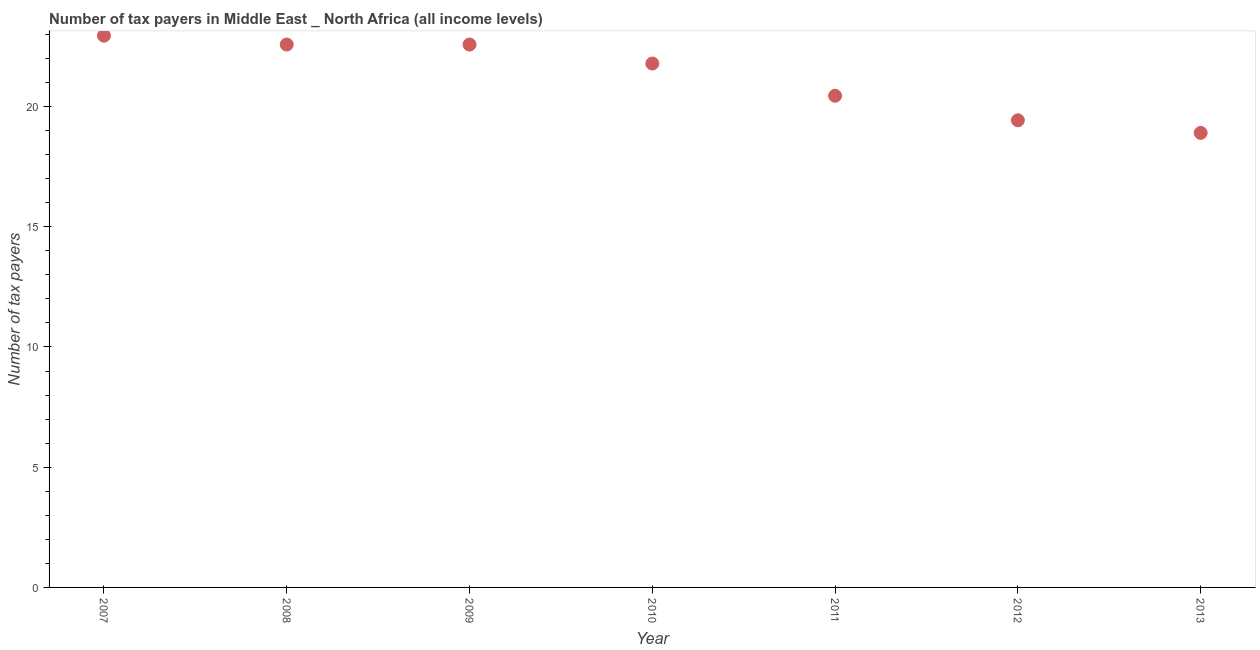What is the number of tax payers in 2011?
Offer a terse response. 20.45. Across all years, what is the maximum number of tax payers?
Give a very brief answer. 22.95. Across all years, what is the minimum number of tax payers?
Keep it short and to the point. 18.9. In which year was the number of tax payers maximum?
Your answer should be compact. 2007. What is the sum of the number of tax payers?
Your answer should be very brief. 148.68. What is the difference between the number of tax payers in 2011 and 2013?
Your answer should be compact. 1.55. What is the average number of tax payers per year?
Offer a terse response. 21.24. What is the median number of tax payers?
Your response must be concise. 21.79. Do a majority of the years between 2011 and 2010 (inclusive) have number of tax payers greater than 7 ?
Your answer should be very brief. No. What is the ratio of the number of tax payers in 2007 to that in 2013?
Offer a terse response. 1.21. What is the difference between the highest and the second highest number of tax payers?
Give a very brief answer. 0.37. Is the sum of the number of tax payers in 2008 and 2013 greater than the maximum number of tax payers across all years?
Your answer should be very brief. Yes. What is the difference between the highest and the lowest number of tax payers?
Make the answer very short. 4.04. Does the number of tax payers monotonically increase over the years?
Keep it short and to the point. No. How many dotlines are there?
Your answer should be compact. 1. Does the graph contain any zero values?
Your response must be concise. No. Does the graph contain grids?
Your response must be concise. No. What is the title of the graph?
Provide a succinct answer. Number of tax payers in Middle East _ North Africa (all income levels). What is the label or title of the Y-axis?
Provide a short and direct response. Number of tax payers. What is the Number of tax payers in 2007?
Make the answer very short. 22.95. What is the Number of tax payers in 2008?
Keep it short and to the point. 22.58. What is the Number of tax payers in 2009?
Your response must be concise. 22.58. What is the Number of tax payers in 2010?
Your response must be concise. 21.79. What is the Number of tax payers in 2011?
Your answer should be compact. 20.45. What is the Number of tax payers in 2012?
Provide a succinct answer. 19.43. What is the Number of tax payers in 2013?
Provide a short and direct response. 18.9. What is the difference between the Number of tax payers in 2007 and 2008?
Your response must be concise. 0.37. What is the difference between the Number of tax payers in 2007 and 2009?
Your answer should be very brief. 0.37. What is the difference between the Number of tax payers in 2007 and 2010?
Give a very brief answer. 1.16. What is the difference between the Number of tax payers in 2007 and 2011?
Ensure brevity in your answer.  2.5. What is the difference between the Number of tax payers in 2007 and 2012?
Offer a very short reply. 3.52. What is the difference between the Number of tax payers in 2007 and 2013?
Your response must be concise. 4.04. What is the difference between the Number of tax payers in 2008 and 2010?
Offer a very short reply. 0.79. What is the difference between the Number of tax payers in 2008 and 2011?
Provide a short and direct response. 2.13. What is the difference between the Number of tax payers in 2008 and 2012?
Your response must be concise. 3.15. What is the difference between the Number of tax payers in 2008 and 2013?
Provide a short and direct response. 3.67. What is the difference between the Number of tax payers in 2009 and 2010?
Offer a terse response. 0.79. What is the difference between the Number of tax payers in 2009 and 2011?
Give a very brief answer. 2.13. What is the difference between the Number of tax payers in 2009 and 2012?
Provide a succinct answer. 3.15. What is the difference between the Number of tax payers in 2009 and 2013?
Provide a short and direct response. 3.67. What is the difference between the Number of tax payers in 2010 and 2011?
Your answer should be compact. 1.34. What is the difference between the Number of tax payers in 2010 and 2012?
Ensure brevity in your answer.  2.36. What is the difference between the Number of tax payers in 2010 and 2013?
Ensure brevity in your answer.  2.88. What is the difference between the Number of tax payers in 2011 and 2012?
Provide a succinct answer. 1.02. What is the difference between the Number of tax payers in 2011 and 2013?
Make the answer very short. 1.55. What is the difference between the Number of tax payers in 2012 and 2013?
Provide a succinct answer. 0.52. What is the ratio of the Number of tax payers in 2007 to that in 2008?
Provide a short and direct response. 1.02. What is the ratio of the Number of tax payers in 2007 to that in 2009?
Your answer should be compact. 1.02. What is the ratio of the Number of tax payers in 2007 to that in 2010?
Make the answer very short. 1.05. What is the ratio of the Number of tax payers in 2007 to that in 2011?
Your answer should be compact. 1.12. What is the ratio of the Number of tax payers in 2007 to that in 2012?
Ensure brevity in your answer.  1.18. What is the ratio of the Number of tax payers in 2007 to that in 2013?
Give a very brief answer. 1.21. What is the ratio of the Number of tax payers in 2008 to that in 2009?
Make the answer very short. 1. What is the ratio of the Number of tax payers in 2008 to that in 2010?
Provide a succinct answer. 1.04. What is the ratio of the Number of tax payers in 2008 to that in 2011?
Your answer should be very brief. 1.1. What is the ratio of the Number of tax payers in 2008 to that in 2012?
Keep it short and to the point. 1.16. What is the ratio of the Number of tax payers in 2008 to that in 2013?
Provide a short and direct response. 1.19. What is the ratio of the Number of tax payers in 2009 to that in 2010?
Your answer should be compact. 1.04. What is the ratio of the Number of tax payers in 2009 to that in 2011?
Your answer should be very brief. 1.1. What is the ratio of the Number of tax payers in 2009 to that in 2012?
Keep it short and to the point. 1.16. What is the ratio of the Number of tax payers in 2009 to that in 2013?
Offer a terse response. 1.19. What is the ratio of the Number of tax payers in 2010 to that in 2011?
Give a very brief answer. 1.06. What is the ratio of the Number of tax payers in 2010 to that in 2012?
Offer a very short reply. 1.12. What is the ratio of the Number of tax payers in 2010 to that in 2013?
Offer a very short reply. 1.15. What is the ratio of the Number of tax payers in 2011 to that in 2012?
Offer a terse response. 1.05. What is the ratio of the Number of tax payers in 2011 to that in 2013?
Ensure brevity in your answer.  1.08. What is the ratio of the Number of tax payers in 2012 to that in 2013?
Your answer should be compact. 1.03. 